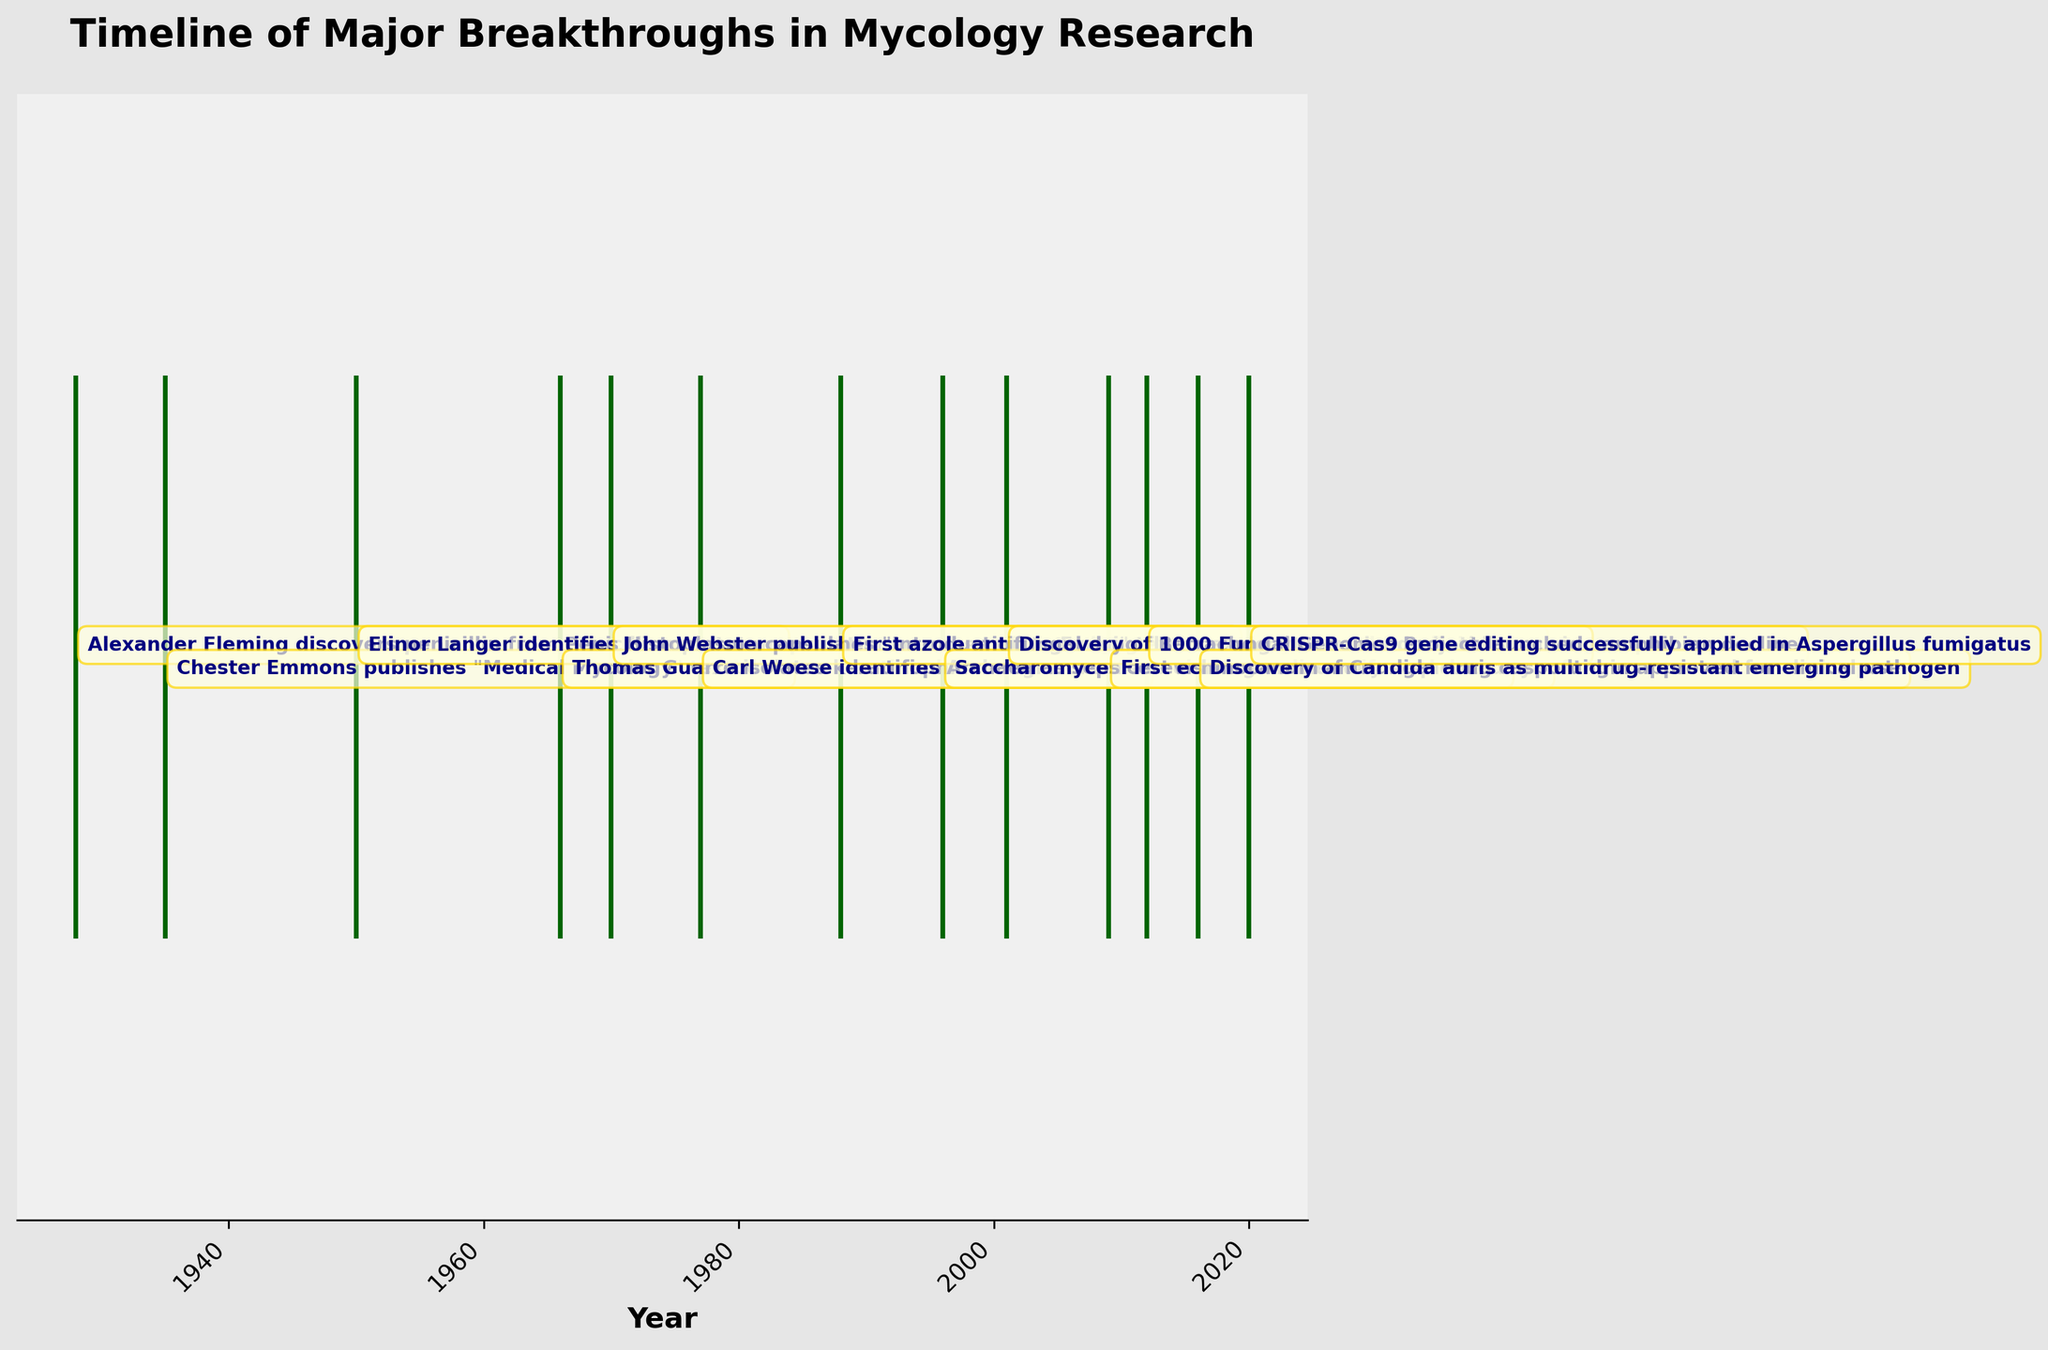When was CRISPR-Cas9 gene editing successfully applied in Aspergillus fumigatus? Locate the event referring to CRISPR-Cas9 gene editing successfully applied in Aspergillus fumigatus on the timeline and note the corresponding year.
Answer: 2020 What was the first azole antifungal drug approved for clinical use, and in what year did this occur? Locate the event on the timeline that refers to the approval of an azole antifungal drug and note its name and the corresponding year.
Answer: Fluconazole, 1988 Which major breakthrough in mycology occurred first, the discovery of penicillin by Alexander Fleming or the identification of Archaea by Carl Woese? Compare the years of the events involving the discovery of penicillin by Alexander Fleming and the identification of Archaea by Carl Woese.
Answer: The discovery of penicillin by Alexander Fleming How many years after the publication of "Medical Mycology" by Chester Emmons was histoplasmosis identified as being caused by Histoplasma capsulatum? Subtract the year Chester Emmons published "Medical Mycology" (1935) from the year Elinor Langer identified Histoplasma capsulatum as causing histoplasmosis (1950).
Answer: 15 Which event happened closer to the year 2000, the full sequencing of the Saccharomyces cerevisiae genome or the identification of Batrachochytrium dendrobatidis causing amphibian decline? Compare the years of the full sequencing of the Saccharomyces cerevisiae genome (1996) and the discovery of Batrachochytrium dendrobatidis causing amphibian decline (2001) to determine which is closer to 2000.
Answer: Identification of Batrachochytrium dendrobatidis What is the average time interval between the major breakthroughs listed in the timeline? Calculate the differences in years between consecutive events and then find the average of these differences. The years are: 1928, 1935, 1950, 1966, 1970, 1977, 1988, 1996, 2001, 2009, 2012, 2016, 2020. Differences are: 7, 15, 16, 4, 7, 11, 8, 5, 8, 3, 4, 4. Average = (7+15+16+4+7+11+8+5+8+3+4+4)/12.
Answer: 8.5 Which breakthrough event marks the midpoint of the timeline, based on the number of events? There are 13 events listed. The midpoint event is the 7th when arranged chronologically. Count the 7th event.
Answer: First azole antifungal drug fluconazole approved for clinical use How many major breakthroughs in mycology research occurred during the 20th century? Count all the events that occurred between the years 1900 and 1999 inclusive. Extract the relevant years and count them: 1928, 1935, 1950, 1966, 1970, 1977, 1988, 1996.
Answer: 8 